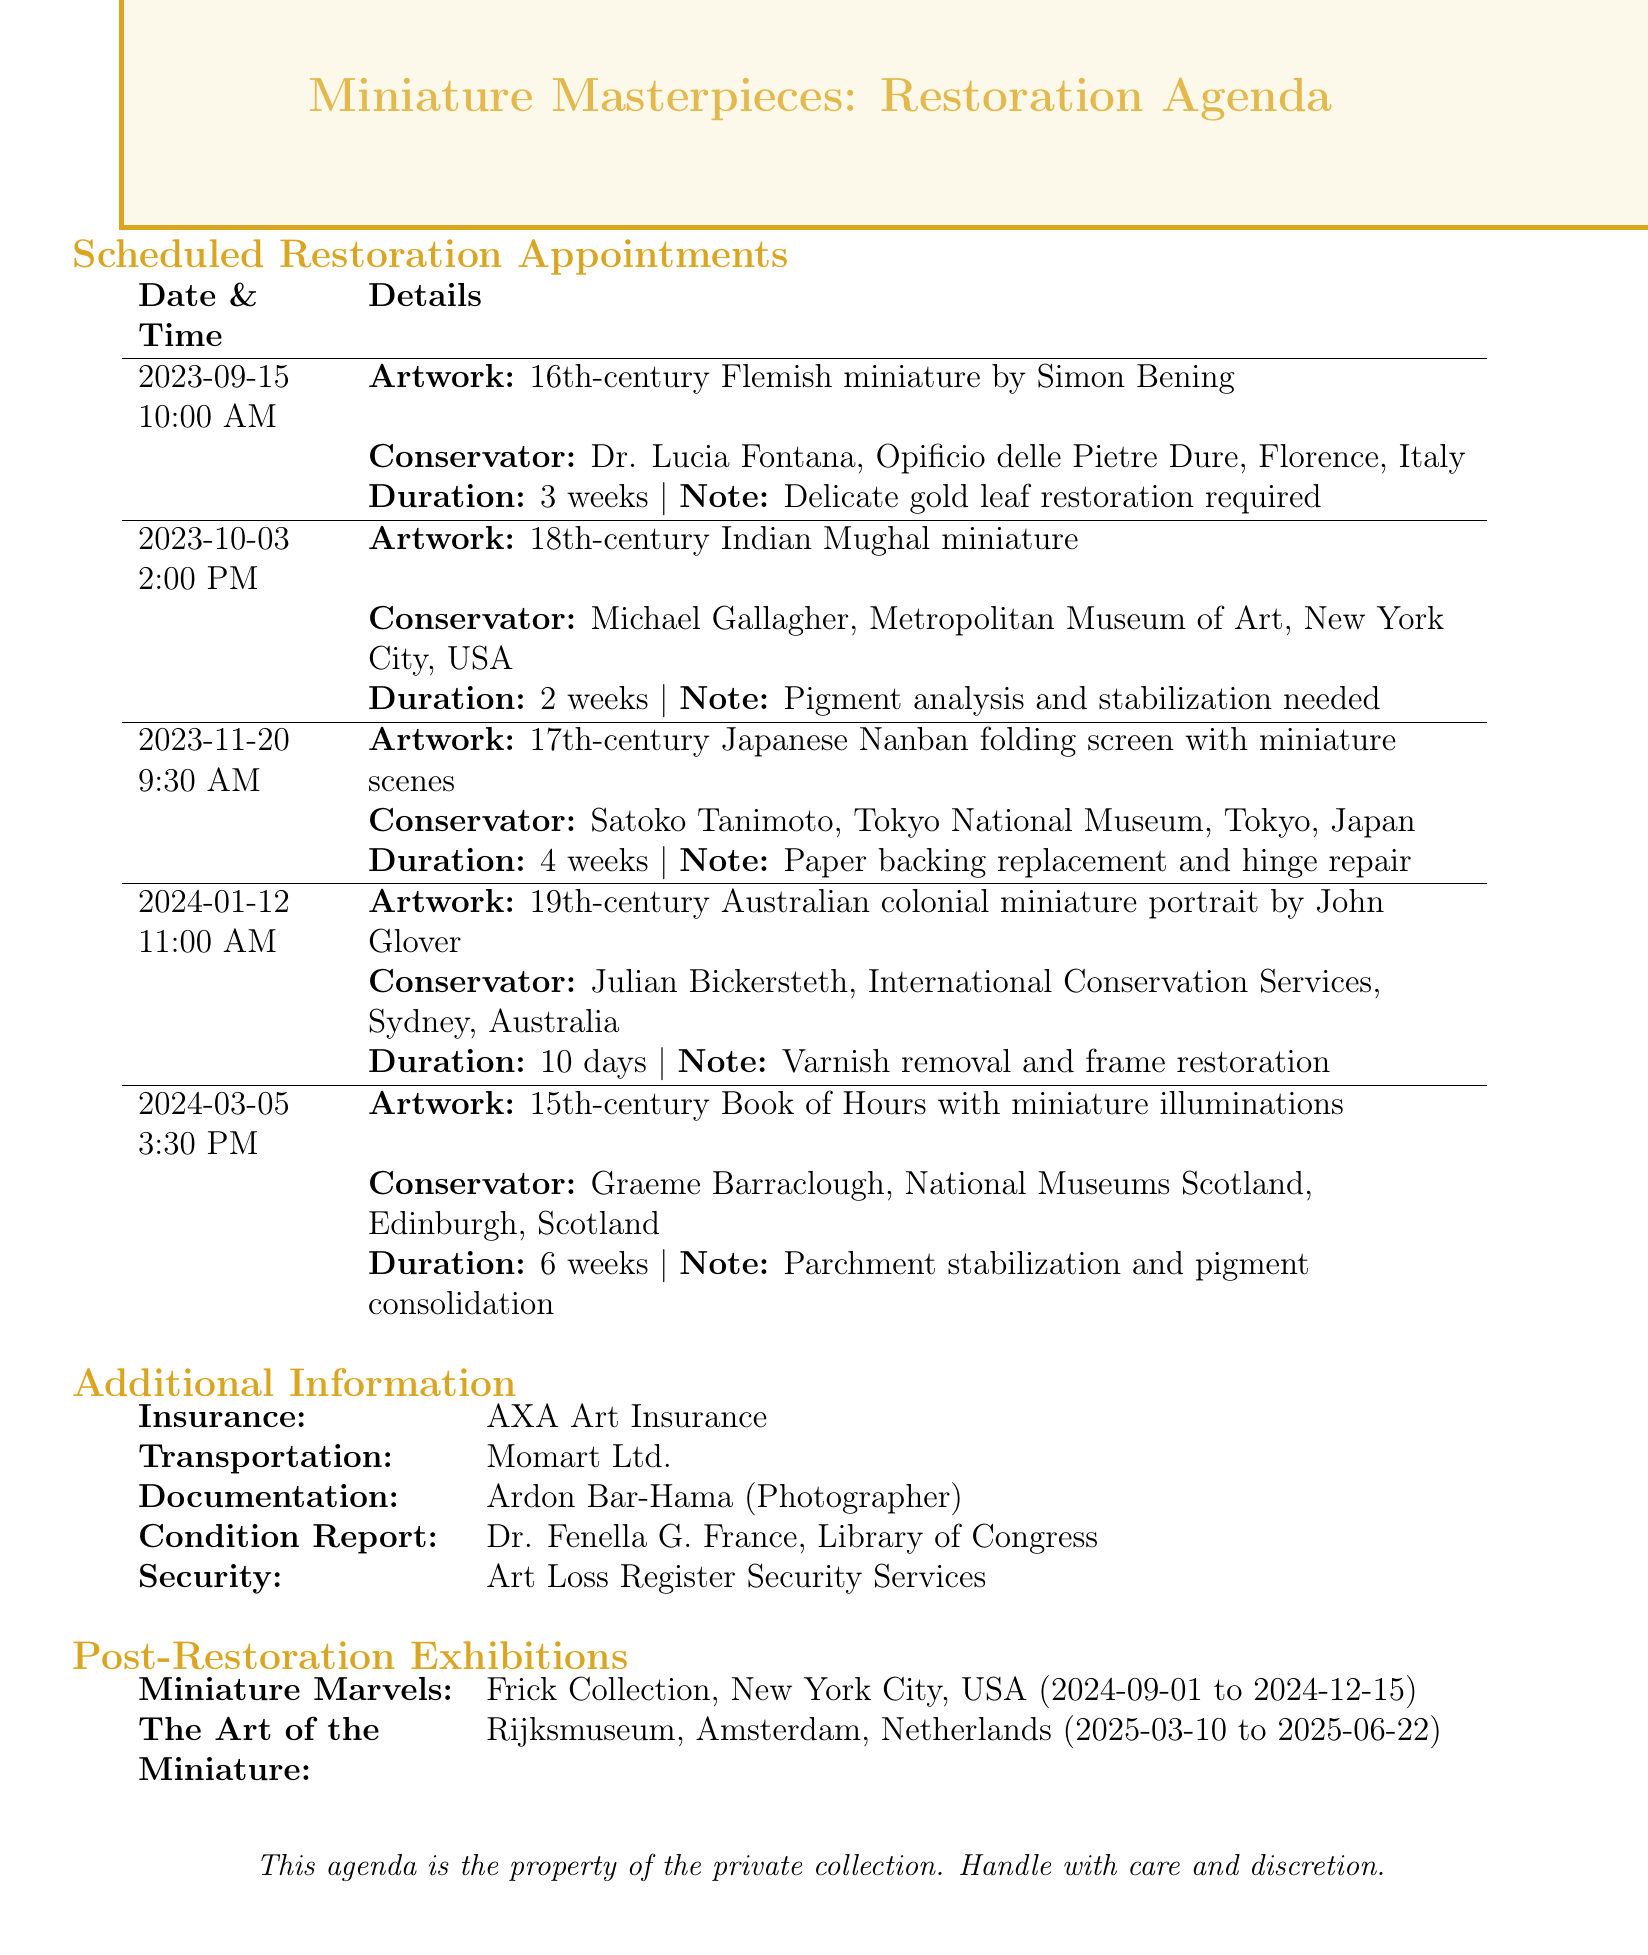What is the date of the first scheduled restoration appointment? The first scheduled restoration appointment is on September 15, 2023.
Answer: September 15, 2023 Who is the conservator for the 18th-century Indian Mughal miniature? The conservator for the 18th-century Indian Mughal miniature is Michael Gallagher.
Answer: Michael Gallagher How long is the estimated duration for the restoration of the 19th-century Australian colonial miniature portrait? The estimated duration for the restoration of the 19th-century Australian colonial miniature portrait is 10 days.
Answer: 10 days What special consideration is needed for the Flemish miniature by Simon Bening? The special consideration needed for the Flemish miniature by Simon Bening is delicate gold leaf restoration.
Answer: Delicate gold leaf restoration Which institution is Dr. Lucia Fontana associated with? Dr. Lucia Fontana is associated with Opificio delle Pietre Dure.
Answer: Opificio delle Pietre Dure What is the location of the exhibition "Miniature Marvels: Restored Treasures"? The location of the exhibition "Miniature Marvels: Restored Treasures" is New York City, USA.
Answer: New York City, USA How many weeks is the estimated duration for the restoration of the 15th-century Book of Hours? The estimated duration for the restoration of the 15th-century Book of Hours is 6 weeks.
Answer: 6 weeks What is the insurance provider listed in the document? The insurance provider listed in the document is AXA Art Insurance.
Answer: AXA Art Insurance What will be restored on the 17th-century Japanese Nanban folding screen? The restoration will include paper backing replacement and hinge repair.
Answer: Paper backing replacement and hinge repair 